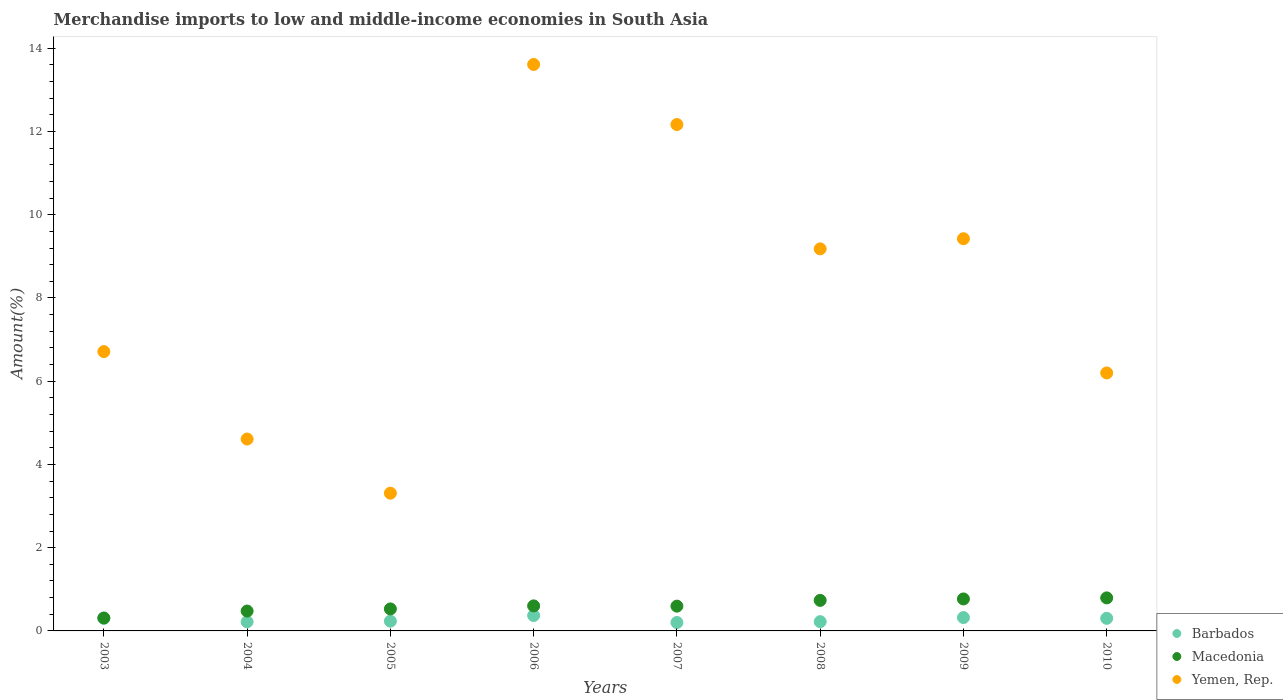How many different coloured dotlines are there?
Make the answer very short. 3. What is the percentage of amount earned from merchandise imports in Macedonia in 2010?
Provide a short and direct response. 0.79. Across all years, what is the maximum percentage of amount earned from merchandise imports in Barbados?
Make the answer very short. 0.37. Across all years, what is the minimum percentage of amount earned from merchandise imports in Barbados?
Keep it short and to the point. 0.2. What is the total percentage of amount earned from merchandise imports in Yemen, Rep. in the graph?
Make the answer very short. 65.22. What is the difference between the percentage of amount earned from merchandise imports in Yemen, Rep. in 2003 and that in 2005?
Your response must be concise. 3.4. What is the difference between the percentage of amount earned from merchandise imports in Barbados in 2004 and the percentage of amount earned from merchandise imports in Macedonia in 2007?
Offer a terse response. -0.38. What is the average percentage of amount earned from merchandise imports in Macedonia per year?
Your response must be concise. 0.6. In the year 2008, what is the difference between the percentage of amount earned from merchandise imports in Macedonia and percentage of amount earned from merchandise imports in Barbados?
Offer a very short reply. 0.51. What is the ratio of the percentage of amount earned from merchandise imports in Macedonia in 2003 to that in 2004?
Keep it short and to the point. 0.65. What is the difference between the highest and the second highest percentage of amount earned from merchandise imports in Macedonia?
Keep it short and to the point. 0.02. What is the difference between the highest and the lowest percentage of amount earned from merchandise imports in Macedonia?
Give a very brief answer. 0.48. Does the percentage of amount earned from merchandise imports in Yemen, Rep. monotonically increase over the years?
Offer a very short reply. No. How many years are there in the graph?
Provide a succinct answer. 8. Where does the legend appear in the graph?
Ensure brevity in your answer.  Bottom right. How are the legend labels stacked?
Keep it short and to the point. Vertical. What is the title of the graph?
Ensure brevity in your answer.  Merchandise imports to low and middle-income economies in South Asia. What is the label or title of the Y-axis?
Provide a succinct answer. Amount(%). What is the Amount(%) in Barbados in 2003?
Provide a succinct answer. 0.3. What is the Amount(%) in Macedonia in 2003?
Provide a short and direct response. 0.31. What is the Amount(%) of Yemen, Rep. in 2003?
Your answer should be compact. 6.71. What is the Amount(%) of Barbados in 2004?
Keep it short and to the point. 0.22. What is the Amount(%) of Macedonia in 2004?
Make the answer very short. 0.48. What is the Amount(%) in Yemen, Rep. in 2004?
Provide a succinct answer. 4.61. What is the Amount(%) in Barbados in 2005?
Your answer should be compact. 0.23. What is the Amount(%) of Macedonia in 2005?
Give a very brief answer. 0.53. What is the Amount(%) of Yemen, Rep. in 2005?
Your answer should be very brief. 3.31. What is the Amount(%) of Barbados in 2006?
Give a very brief answer. 0.37. What is the Amount(%) of Macedonia in 2006?
Provide a short and direct response. 0.6. What is the Amount(%) of Yemen, Rep. in 2006?
Make the answer very short. 13.61. What is the Amount(%) in Barbados in 2007?
Your answer should be compact. 0.2. What is the Amount(%) of Macedonia in 2007?
Your response must be concise. 0.6. What is the Amount(%) of Yemen, Rep. in 2007?
Provide a short and direct response. 12.17. What is the Amount(%) in Barbados in 2008?
Make the answer very short. 0.22. What is the Amount(%) in Macedonia in 2008?
Provide a short and direct response. 0.73. What is the Amount(%) in Yemen, Rep. in 2008?
Your response must be concise. 9.18. What is the Amount(%) of Barbados in 2009?
Ensure brevity in your answer.  0.32. What is the Amount(%) of Macedonia in 2009?
Provide a succinct answer. 0.77. What is the Amount(%) of Yemen, Rep. in 2009?
Your answer should be very brief. 9.42. What is the Amount(%) of Barbados in 2010?
Provide a succinct answer. 0.3. What is the Amount(%) of Macedonia in 2010?
Your answer should be very brief. 0.79. What is the Amount(%) in Yemen, Rep. in 2010?
Make the answer very short. 6.2. Across all years, what is the maximum Amount(%) of Barbados?
Offer a very short reply. 0.37. Across all years, what is the maximum Amount(%) in Macedonia?
Provide a short and direct response. 0.79. Across all years, what is the maximum Amount(%) in Yemen, Rep.?
Provide a short and direct response. 13.61. Across all years, what is the minimum Amount(%) of Barbados?
Keep it short and to the point. 0.2. Across all years, what is the minimum Amount(%) in Macedonia?
Ensure brevity in your answer.  0.31. Across all years, what is the minimum Amount(%) of Yemen, Rep.?
Offer a terse response. 3.31. What is the total Amount(%) of Barbados in the graph?
Ensure brevity in your answer.  2.18. What is the total Amount(%) in Macedonia in the graph?
Your response must be concise. 4.81. What is the total Amount(%) in Yemen, Rep. in the graph?
Give a very brief answer. 65.22. What is the difference between the Amount(%) in Barbados in 2003 and that in 2004?
Provide a succinct answer. 0.09. What is the difference between the Amount(%) of Macedonia in 2003 and that in 2004?
Your answer should be very brief. -0.17. What is the difference between the Amount(%) in Yemen, Rep. in 2003 and that in 2004?
Keep it short and to the point. 2.1. What is the difference between the Amount(%) in Barbados in 2003 and that in 2005?
Offer a terse response. 0.07. What is the difference between the Amount(%) in Macedonia in 2003 and that in 2005?
Your response must be concise. -0.22. What is the difference between the Amount(%) of Yemen, Rep. in 2003 and that in 2005?
Make the answer very short. 3.4. What is the difference between the Amount(%) of Barbados in 2003 and that in 2006?
Your answer should be very brief. -0.07. What is the difference between the Amount(%) in Macedonia in 2003 and that in 2006?
Your answer should be compact. -0.29. What is the difference between the Amount(%) in Yemen, Rep. in 2003 and that in 2006?
Give a very brief answer. -6.9. What is the difference between the Amount(%) of Barbados in 2003 and that in 2007?
Keep it short and to the point. 0.1. What is the difference between the Amount(%) in Macedonia in 2003 and that in 2007?
Provide a short and direct response. -0.28. What is the difference between the Amount(%) of Yemen, Rep. in 2003 and that in 2007?
Provide a succinct answer. -5.46. What is the difference between the Amount(%) in Barbados in 2003 and that in 2008?
Provide a short and direct response. 0.08. What is the difference between the Amount(%) in Macedonia in 2003 and that in 2008?
Give a very brief answer. -0.42. What is the difference between the Amount(%) of Yemen, Rep. in 2003 and that in 2008?
Give a very brief answer. -2.47. What is the difference between the Amount(%) in Barbados in 2003 and that in 2009?
Provide a succinct answer. -0.02. What is the difference between the Amount(%) in Macedonia in 2003 and that in 2009?
Your answer should be very brief. -0.46. What is the difference between the Amount(%) in Yemen, Rep. in 2003 and that in 2009?
Make the answer very short. -2.71. What is the difference between the Amount(%) of Barbados in 2003 and that in 2010?
Make the answer very short. 0. What is the difference between the Amount(%) of Macedonia in 2003 and that in 2010?
Ensure brevity in your answer.  -0.48. What is the difference between the Amount(%) in Yemen, Rep. in 2003 and that in 2010?
Provide a succinct answer. 0.51. What is the difference between the Amount(%) in Barbados in 2004 and that in 2005?
Keep it short and to the point. -0.02. What is the difference between the Amount(%) in Macedonia in 2004 and that in 2005?
Offer a terse response. -0.05. What is the difference between the Amount(%) in Yemen, Rep. in 2004 and that in 2005?
Your response must be concise. 1.3. What is the difference between the Amount(%) in Barbados in 2004 and that in 2006?
Provide a succinct answer. -0.15. What is the difference between the Amount(%) of Macedonia in 2004 and that in 2006?
Provide a succinct answer. -0.12. What is the difference between the Amount(%) of Yemen, Rep. in 2004 and that in 2006?
Provide a succinct answer. -9. What is the difference between the Amount(%) of Barbados in 2004 and that in 2007?
Offer a terse response. 0.02. What is the difference between the Amount(%) in Macedonia in 2004 and that in 2007?
Provide a short and direct response. -0.12. What is the difference between the Amount(%) of Yemen, Rep. in 2004 and that in 2007?
Offer a terse response. -7.56. What is the difference between the Amount(%) of Barbados in 2004 and that in 2008?
Your answer should be very brief. -0. What is the difference between the Amount(%) in Macedonia in 2004 and that in 2008?
Keep it short and to the point. -0.26. What is the difference between the Amount(%) in Yemen, Rep. in 2004 and that in 2008?
Offer a terse response. -4.57. What is the difference between the Amount(%) in Barbados in 2004 and that in 2009?
Ensure brevity in your answer.  -0.1. What is the difference between the Amount(%) of Macedonia in 2004 and that in 2009?
Give a very brief answer. -0.29. What is the difference between the Amount(%) in Yemen, Rep. in 2004 and that in 2009?
Provide a succinct answer. -4.81. What is the difference between the Amount(%) in Barbados in 2004 and that in 2010?
Your answer should be very brief. -0.08. What is the difference between the Amount(%) in Macedonia in 2004 and that in 2010?
Give a very brief answer. -0.32. What is the difference between the Amount(%) of Yemen, Rep. in 2004 and that in 2010?
Your answer should be compact. -1.59. What is the difference between the Amount(%) of Barbados in 2005 and that in 2006?
Provide a short and direct response. -0.14. What is the difference between the Amount(%) of Macedonia in 2005 and that in 2006?
Ensure brevity in your answer.  -0.07. What is the difference between the Amount(%) in Yemen, Rep. in 2005 and that in 2006?
Provide a short and direct response. -10.3. What is the difference between the Amount(%) in Barbados in 2005 and that in 2007?
Your answer should be compact. 0.03. What is the difference between the Amount(%) of Macedonia in 2005 and that in 2007?
Provide a short and direct response. -0.07. What is the difference between the Amount(%) in Yemen, Rep. in 2005 and that in 2007?
Ensure brevity in your answer.  -8.86. What is the difference between the Amount(%) in Barbados in 2005 and that in 2008?
Provide a succinct answer. 0.01. What is the difference between the Amount(%) of Macedonia in 2005 and that in 2008?
Your response must be concise. -0.21. What is the difference between the Amount(%) of Yemen, Rep. in 2005 and that in 2008?
Your response must be concise. -5.87. What is the difference between the Amount(%) in Barbados in 2005 and that in 2009?
Give a very brief answer. -0.09. What is the difference between the Amount(%) of Macedonia in 2005 and that in 2009?
Provide a short and direct response. -0.24. What is the difference between the Amount(%) of Yemen, Rep. in 2005 and that in 2009?
Make the answer very short. -6.11. What is the difference between the Amount(%) of Barbados in 2005 and that in 2010?
Provide a succinct answer. -0.07. What is the difference between the Amount(%) in Macedonia in 2005 and that in 2010?
Keep it short and to the point. -0.26. What is the difference between the Amount(%) of Yemen, Rep. in 2005 and that in 2010?
Provide a short and direct response. -2.89. What is the difference between the Amount(%) of Barbados in 2006 and that in 2007?
Ensure brevity in your answer.  0.17. What is the difference between the Amount(%) of Macedonia in 2006 and that in 2007?
Ensure brevity in your answer.  0.01. What is the difference between the Amount(%) of Yemen, Rep. in 2006 and that in 2007?
Your answer should be very brief. 1.44. What is the difference between the Amount(%) in Barbados in 2006 and that in 2008?
Give a very brief answer. 0.15. What is the difference between the Amount(%) of Macedonia in 2006 and that in 2008?
Your answer should be very brief. -0.13. What is the difference between the Amount(%) in Yemen, Rep. in 2006 and that in 2008?
Ensure brevity in your answer.  4.43. What is the difference between the Amount(%) in Barbados in 2006 and that in 2009?
Provide a short and direct response. 0.05. What is the difference between the Amount(%) of Macedonia in 2006 and that in 2009?
Keep it short and to the point. -0.17. What is the difference between the Amount(%) in Yemen, Rep. in 2006 and that in 2009?
Provide a short and direct response. 4.19. What is the difference between the Amount(%) of Barbados in 2006 and that in 2010?
Your answer should be compact. 0.07. What is the difference between the Amount(%) in Macedonia in 2006 and that in 2010?
Your answer should be very brief. -0.19. What is the difference between the Amount(%) in Yemen, Rep. in 2006 and that in 2010?
Your answer should be very brief. 7.41. What is the difference between the Amount(%) of Barbados in 2007 and that in 2008?
Your response must be concise. -0.02. What is the difference between the Amount(%) in Macedonia in 2007 and that in 2008?
Your response must be concise. -0.14. What is the difference between the Amount(%) in Yemen, Rep. in 2007 and that in 2008?
Provide a succinct answer. 2.99. What is the difference between the Amount(%) of Barbados in 2007 and that in 2009?
Your response must be concise. -0.12. What is the difference between the Amount(%) in Macedonia in 2007 and that in 2009?
Provide a short and direct response. -0.17. What is the difference between the Amount(%) of Yemen, Rep. in 2007 and that in 2009?
Offer a very short reply. 2.74. What is the difference between the Amount(%) of Barbados in 2007 and that in 2010?
Give a very brief answer. -0.1. What is the difference between the Amount(%) in Macedonia in 2007 and that in 2010?
Give a very brief answer. -0.2. What is the difference between the Amount(%) of Yemen, Rep. in 2007 and that in 2010?
Make the answer very short. 5.97. What is the difference between the Amount(%) of Barbados in 2008 and that in 2009?
Ensure brevity in your answer.  -0.1. What is the difference between the Amount(%) in Macedonia in 2008 and that in 2009?
Keep it short and to the point. -0.03. What is the difference between the Amount(%) of Yemen, Rep. in 2008 and that in 2009?
Your response must be concise. -0.24. What is the difference between the Amount(%) in Barbados in 2008 and that in 2010?
Make the answer very short. -0.08. What is the difference between the Amount(%) in Macedonia in 2008 and that in 2010?
Ensure brevity in your answer.  -0.06. What is the difference between the Amount(%) in Yemen, Rep. in 2008 and that in 2010?
Make the answer very short. 2.98. What is the difference between the Amount(%) in Barbados in 2009 and that in 2010?
Give a very brief answer. 0.02. What is the difference between the Amount(%) in Macedonia in 2009 and that in 2010?
Your response must be concise. -0.03. What is the difference between the Amount(%) in Yemen, Rep. in 2009 and that in 2010?
Offer a very short reply. 3.23. What is the difference between the Amount(%) in Barbados in 2003 and the Amount(%) in Macedonia in 2004?
Provide a succinct answer. -0.17. What is the difference between the Amount(%) in Barbados in 2003 and the Amount(%) in Yemen, Rep. in 2004?
Offer a very short reply. -4.31. What is the difference between the Amount(%) in Macedonia in 2003 and the Amount(%) in Yemen, Rep. in 2004?
Your response must be concise. -4.3. What is the difference between the Amount(%) of Barbados in 2003 and the Amount(%) of Macedonia in 2005?
Your answer should be compact. -0.23. What is the difference between the Amount(%) in Barbados in 2003 and the Amount(%) in Yemen, Rep. in 2005?
Your answer should be compact. -3.01. What is the difference between the Amount(%) in Macedonia in 2003 and the Amount(%) in Yemen, Rep. in 2005?
Provide a succinct answer. -3. What is the difference between the Amount(%) in Barbados in 2003 and the Amount(%) in Macedonia in 2006?
Give a very brief answer. -0.3. What is the difference between the Amount(%) in Barbados in 2003 and the Amount(%) in Yemen, Rep. in 2006?
Your response must be concise. -13.31. What is the difference between the Amount(%) in Macedonia in 2003 and the Amount(%) in Yemen, Rep. in 2006?
Your answer should be compact. -13.3. What is the difference between the Amount(%) of Barbados in 2003 and the Amount(%) of Macedonia in 2007?
Your response must be concise. -0.29. What is the difference between the Amount(%) in Barbados in 2003 and the Amount(%) in Yemen, Rep. in 2007?
Your answer should be very brief. -11.86. What is the difference between the Amount(%) of Macedonia in 2003 and the Amount(%) of Yemen, Rep. in 2007?
Ensure brevity in your answer.  -11.86. What is the difference between the Amount(%) in Barbados in 2003 and the Amount(%) in Macedonia in 2008?
Offer a very short reply. -0.43. What is the difference between the Amount(%) in Barbados in 2003 and the Amount(%) in Yemen, Rep. in 2008?
Keep it short and to the point. -8.88. What is the difference between the Amount(%) of Macedonia in 2003 and the Amount(%) of Yemen, Rep. in 2008?
Provide a succinct answer. -8.87. What is the difference between the Amount(%) in Barbados in 2003 and the Amount(%) in Macedonia in 2009?
Provide a succinct answer. -0.46. What is the difference between the Amount(%) of Barbados in 2003 and the Amount(%) of Yemen, Rep. in 2009?
Make the answer very short. -9.12. What is the difference between the Amount(%) of Macedonia in 2003 and the Amount(%) of Yemen, Rep. in 2009?
Provide a short and direct response. -9.11. What is the difference between the Amount(%) of Barbados in 2003 and the Amount(%) of Macedonia in 2010?
Offer a terse response. -0.49. What is the difference between the Amount(%) in Barbados in 2003 and the Amount(%) in Yemen, Rep. in 2010?
Offer a terse response. -5.9. What is the difference between the Amount(%) of Macedonia in 2003 and the Amount(%) of Yemen, Rep. in 2010?
Offer a terse response. -5.89. What is the difference between the Amount(%) in Barbados in 2004 and the Amount(%) in Macedonia in 2005?
Give a very brief answer. -0.31. What is the difference between the Amount(%) of Barbados in 2004 and the Amount(%) of Yemen, Rep. in 2005?
Provide a succinct answer. -3.09. What is the difference between the Amount(%) in Macedonia in 2004 and the Amount(%) in Yemen, Rep. in 2005?
Your answer should be compact. -2.83. What is the difference between the Amount(%) in Barbados in 2004 and the Amount(%) in Macedonia in 2006?
Give a very brief answer. -0.38. What is the difference between the Amount(%) of Barbados in 2004 and the Amount(%) of Yemen, Rep. in 2006?
Keep it short and to the point. -13.39. What is the difference between the Amount(%) in Macedonia in 2004 and the Amount(%) in Yemen, Rep. in 2006?
Provide a short and direct response. -13.13. What is the difference between the Amount(%) in Barbados in 2004 and the Amount(%) in Macedonia in 2007?
Provide a short and direct response. -0.38. What is the difference between the Amount(%) in Barbados in 2004 and the Amount(%) in Yemen, Rep. in 2007?
Provide a short and direct response. -11.95. What is the difference between the Amount(%) of Macedonia in 2004 and the Amount(%) of Yemen, Rep. in 2007?
Your answer should be compact. -11.69. What is the difference between the Amount(%) of Barbados in 2004 and the Amount(%) of Macedonia in 2008?
Make the answer very short. -0.52. What is the difference between the Amount(%) in Barbados in 2004 and the Amount(%) in Yemen, Rep. in 2008?
Provide a succinct answer. -8.96. What is the difference between the Amount(%) in Macedonia in 2004 and the Amount(%) in Yemen, Rep. in 2008?
Provide a short and direct response. -8.7. What is the difference between the Amount(%) in Barbados in 2004 and the Amount(%) in Macedonia in 2009?
Provide a short and direct response. -0.55. What is the difference between the Amount(%) of Barbados in 2004 and the Amount(%) of Yemen, Rep. in 2009?
Provide a succinct answer. -9.21. What is the difference between the Amount(%) in Macedonia in 2004 and the Amount(%) in Yemen, Rep. in 2009?
Your response must be concise. -8.95. What is the difference between the Amount(%) in Barbados in 2004 and the Amount(%) in Macedonia in 2010?
Your answer should be very brief. -0.58. What is the difference between the Amount(%) of Barbados in 2004 and the Amount(%) of Yemen, Rep. in 2010?
Your response must be concise. -5.98. What is the difference between the Amount(%) in Macedonia in 2004 and the Amount(%) in Yemen, Rep. in 2010?
Offer a very short reply. -5.72. What is the difference between the Amount(%) in Barbados in 2005 and the Amount(%) in Macedonia in 2006?
Your answer should be very brief. -0.37. What is the difference between the Amount(%) of Barbados in 2005 and the Amount(%) of Yemen, Rep. in 2006?
Your answer should be compact. -13.38. What is the difference between the Amount(%) in Macedonia in 2005 and the Amount(%) in Yemen, Rep. in 2006?
Ensure brevity in your answer.  -13.08. What is the difference between the Amount(%) of Barbados in 2005 and the Amount(%) of Macedonia in 2007?
Your answer should be very brief. -0.36. What is the difference between the Amount(%) of Barbados in 2005 and the Amount(%) of Yemen, Rep. in 2007?
Your answer should be compact. -11.93. What is the difference between the Amount(%) in Macedonia in 2005 and the Amount(%) in Yemen, Rep. in 2007?
Provide a succinct answer. -11.64. What is the difference between the Amount(%) of Barbados in 2005 and the Amount(%) of Macedonia in 2008?
Provide a succinct answer. -0.5. What is the difference between the Amount(%) in Barbados in 2005 and the Amount(%) in Yemen, Rep. in 2008?
Ensure brevity in your answer.  -8.95. What is the difference between the Amount(%) in Macedonia in 2005 and the Amount(%) in Yemen, Rep. in 2008?
Your answer should be very brief. -8.65. What is the difference between the Amount(%) of Barbados in 2005 and the Amount(%) of Macedonia in 2009?
Provide a succinct answer. -0.53. What is the difference between the Amount(%) in Barbados in 2005 and the Amount(%) in Yemen, Rep. in 2009?
Give a very brief answer. -9.19. What is the difference between the Amount(%) in Macedonia in 2005 and the Amount(%) in Yemen, Rep. in 2009?
Offer a terse response. -8.9. What is the difference between the Amount(%) in Barbados in 2005 and the Amount(%) in Macedonia in 2010?
Keep it short and to the point. -0.56. What is the difference between the Amount(%) of Barbados in 2005 and the Amount(%) of Yemen, Rep. in 2010?
Your answer should be very brief. -5.96. What is the difference between the Amount(%) of Macedonia in 2005 and the Amount(%) of Yemen, Rep. in 2010?
Offer a terse response. -5.67. What is the difference between the Amount(%) in Barbados in 2006 and the Amount(%) in Macedonia in 2007?
Provide a short and direct response. -0.23. What is the difference between the Amount(%) in Barbados in 2006 and the Amount(%) in Yemen, Rep. in 2007?
Give a very brief answer. -11.8. What is the difference between the Amount(%) in Macedonia in 2006 and the Amount(%) in Yemen, Rep. in 2007?
Keep it short and to the point. -11.57. What is the difference between the Amount(%) in Barbados in 2006 and the Amount(%) in Macedonia in 2008?
Your answer should be compact. -0.36. What is the difference between the Amount(%) in Barbados in 2006 and the Amount(%) in Yemen, Rep. in 2008?
Provide a succinct answer. -8.81. What is the difference between the Amount(%) in Macedonia in 2006 and the Amount(%) in Yemen, Rep. in 2008?
Your answer should be compact. -8.58. What is the difference between the Amount(%) in Barbados in 2006 and the Amount(%) in Macedonia in 2009?
Keep it short and to the point. -0.4. What is the difference between the Amount(%) in Barbados in 2006 and the Amount(%) in Yemen, Rep. in 2009?
Offer a terse response. -9.05. What is the difference between the Amount(%) in Macedonia in 2006 and the Amount(%) in Yemen, Rep. in 2009?
Your answer should be compact. -8.82. What is the difference between the Amount(%) in Barbados in 2006 and the Amount(%) in Macedonia in 2010?
Offer a very short reply. -0.42. What is the difference between the Amount(%) in Barbados in 2006 and the Amount(%) in Yemen, Rep. in 2010?
Your answer should be very brief. -5.83. What is the difference between the Amount(%) in Macedonia in 2006 and the Amount(%) in Yemen, Rep. in 2010?
Your answer should be very brief. -5.6. What is the difference between the Amount(%) in Barbados in 2007 and the Amount(%) in Macedonia in 2008?
Give a very brief answer. -0.53. What is the difference between the Amount(%) of Barbados in 2007 and the Amount(%) of Yemen, Rep. in 2008?
Your response must be concise. -8.98. What is the difference between the Amount(%) in Macedonia in 2007 and the Amount(%) in Yemen, Rep. in 2008?
Provide a succinct answer. -8.59. What is the difference between the Amount(%) of Barbados in 2007 and the Amount(%) of Macedonia in 2009?
Offer a very short reply. -0.57. What is the difference between the Amount(%) of Barbados in 2007 and the Amount(%) of Yemen, Rep. in 2009?
Your response must be concise. -9.22. What is the difference between the Amount(%) of Macedonia in 2007 and the Amount(%) of Yemen, Rep. in 2009?
Give a very brief answer. -8.83. What is the difference between the Amount(%) in Barbados in 2007 and the Amount(%) in Macedonia in 2010?
Offer a terse response. -0.59. What is the difference between the Amount(%) of Barbados in 2007 and the Amount(%) of Yemen, Rep. in 2010?
Provide a short and direct response. -6. What is the difference between the Amount(%) of Macedonia in 2007 and the Amount(%) of Yemen, Rep. in 2010?
Keep it short and to the point. -5.6. What is the difference between the Amount(%) of Barbados in 2008 and the Amount(%) of Macedonia in 2009?
Keep it short and to the point. -0.55. What is the difference between the Amount(%) in Barbados in 2008 and the Amount(%) in Yemen, Rep. in 2009?
Provide a short and direct response. -9.2. What is the difference between the Amount(%) in Macedonia in 2008 and the Amount(%) in Yemen, Rep. in 2009?
Your response must be concise. -8.69. What is the difference between the Amount(%) of Barbados in 2008 and the Amount(%) of Macedonia in 2010?
Ensure brevity in your answer.  -0.57. What is the difference between the Amount(%) in Barbados in 2008 and the Amount(%) in Yemen, Rep. in 2010?
Provide a succinct answer. -5.98. What is the difference between the Amount(%) of Macedonia in 2008 and the Amount(%) of Yemen, Rep. in 2010?
Offer a terse response. -5.46. What is the difference between the Amount(%) in Barbados in 2009 and the Amount(%) in Macedonia in 2010?
Provide a succinct answer. -0.47. What is the difference between the Amount(%) of Barbados in 2009 and the Amount(%) of Yemen, Rep. in 2010?
Offer a terse response. -5.88. What is the difference between the Amount(%) in Macedonia in 2009 and the Amount(%) in Yemen, Rep. in 2010?
Your response must be concise. -5.43. What is the average Amount(%) of Barbados per year?
Offer a terse response. 0.27. What is the average Amount(%) of Macedonia per year?
Make the answer very short. 0.6. What is the average Amount(%) in Yemen, Rep. per year?
Offer a very short reply. 8.15. In the year 2003, what is the difference between the Amount(%) in Barbados and Amount(%) in Macedonia?
Offer a very short reply. -0.01. In the year 2003, what is the difference between the Amount(%) of Barbados and Amount(%) of Yemen, Rep.?
Provide a succinct answer. -6.41. In the year 2003, what is the difference between the Amount(%) in Macedonia and Amount(%) in Yemen, Rep.?
Offer a terse response. -6.4. In the year 2004, what is the difference between the Amount(%) in Barbados and Amount(%) in Macedonia?
Ensure brevity in your answer.  -0.26. In the year 2004, what is the difference between the Amount(%) of Barbados and Amount(%) of Yemen, Rep.?
Make the answer very short. -4.39. In the year 2004, what is the difference between the Amount(%) in Macedonia and Amount(%) in Yemen, Rep.?
Provide a short and direct response. -4.13. In the year 2005, what is the difference between the Amount(%) in Barbados and Amount(%) in Macedonia?
Offer a very short reply. -0.29. In the year 2005, what is the difference between the Amount(%) in Barbados and Amount(%) in Yemen, Rep.?
Offer a terse response. -3.08. In the year 2005, what is the difference between the Amount(%) in Macedonia and Amount(%) in Yemen, Rep.?
Give a very brief answer. -2.78. In the year 2006, what is the difference between the Amount(%) of Barbados and Amount(%) of Macedonia?
Your answer should be very brief. -0.23. In the year 2006, what is the difference between the Amount(%) of Barbados and Amount(%) of Yemen, Rep.?
Offer a very short reply. -13.24. In the year 2006, what is the difference between the Amount(%) in Macedonia and Amount(%) in Yemen, Rep.?
Give a very brief answer. -13.01. In the year 2007, what is the difference between the Amount(%) of Barbados and Amount(%) of Macedonia?
Provide a short and direct response. -0.39. In the year 2007, what is the difference between the Amount(%) of Barbados and Amount(%) of Yemen, Rep.?
Your response must be concise. -11.97. In the year 2007, what is the difference between the Amount(%) in Macedonia and Amount(%) in Yemen, Rep.?
Provide a succinct answer. -11.57. In the year 2008, what is the difference between the Amount(%) of Barbados and Amount(%) of Macedonia?
Your response must be concise. -0.51. In the year 2008, what is the difference between the Amount(%) in Barbados and Amount(%) in Yemen, Rep.?
Make the answer very short. -8.96. In the year 2008, what is the difference between the Amount(%) of Macedonia and Amount(%) of Yemen, Rep.?
Provide a short and direct response. -8.45. In the year 2009, what is the difference between the Amount(%) of Barbados and Amount(%) of Macedonia?
Make the answer very short. -0.45. In the year 2009, what is the difference between the Amount(%) of Barbados and Amount(%) of Yemen, Rep.?
Ensure brevity in your answer.  -9.1. In the year 2009, what is the difference between the Amount(%) of Macedonia and Amount(%) of Yemen, Rep.?
Offer a very short reply. -8.66. In the year 2010, what is the difference between the Amount(%) in Barbados and Amount(%) in Macedonia?
Keep it short and to the point. -0.49. In the year 2010, what is the difference between the Amount(%) of Barbados and Amount(%) of Yemen, Rep.?
Offer a very short reply. -5.9. In the year 2010, what is the difference between the Amount(%) of Macedonia and Amount(%) of Yemen, Rep.?
Offer a very short reply. -5.41. What is the ratio of the Amount(%) of Barbados in 2003 to that in 2004?
Make the answer very short. 1.39. What is the ratio of the Amount(%) in Macedonia in 2003 to that in 2004?
Offer a very short reply. 0.65. What is the ratio of the Amount(%) in Yemen, Rep. in 2003 to that in 2004?
Ensure brevity in your answer.  1.46. What is the ratio of the Amount(%) in Barbados in 2003 to that in 2005?
Offer a terse response. 1.29. What is the ratio of the Amount(%) of Macedonia in 2003 to that in 2005?
Offer a very short reply. 0.59. What is the ratio of the Amount(%) of Yemen, Rep. in 2003 to that in 2005?
Your answer should be compact. 2.03. What is the ratio of the Amount(%) in Barbados in 2003 to that in 2006?
Your answer should be very brief. 0.82. What is the ratio of the Amount(%) of Macedonia in 2003 to that in 2006?
Ensure brevity in your answer.  0.52. What is the ratio of the Amount(%) of Yemen, Rep. in 2003 to that in 2006?
Your response must be concise. 0.49. What is the ratio of the Amount(%) of Barbados in 2003 to that in 2007?
Make the answer very short. 1.5. What is the ratio of the Amount(%) in Macedonia in 2003 to that in 2007?
Your answer should be very brief. 0.52. What is the ratio of the Amount(%) of Yemen, Rep. in 2003 to that in 2007?
Keep it short and to the point. 0.55. What is the ratio of the Amount(%) of Barbados in 2003 to that in 2008?
Provide a succinct answer. 1.36. What is the ratio of the Amount(%) of Macedonia in 2003 to that in 2008?
Provide a short and direct response. 0.42. What is the ratio of the Amount(%) of Yemen, Rep. in 2003 to that in 2008?
Your response must be concise. 0.73. What is the ratio of the Amount(%) in Barbados in 2003 to that in 2009?
Make the answer very short. 0.95. What is the ratio of the Amount(%) in Macedonia in 2003 to that in 2009?
Provide a succinct answer. 0.4. What is the ratio of the Amount(%) in Yemen, Rep. in 2003 to that in 2009?
Ensure brevity in your answer.  0.71. What is the ratio of the Amount(%) of Macedonia in 2003 to that in 2010?
Offer a terse response. 0.39. What is the ratio of the Amount(%) in Yemen, Rep. in 2003 to that in 2010?
Your answer should be compact. 1.08. What is the ratio of the Amount(%) in Barbados in 2004 to that in 2005?
Provide a succinct answer. 0.93. What is the ratio of the Amount(%) of Macedonia in 2004 to that in 2005?
Your response must be concise. 0.9. What is the ratio of the Amount(%) of Yemen, Rep. in 2004 to that in 2005?
Your answer should be very brief. 1.39. What is the ratio of the Amount(%) of Barbados in 2004 to that in 2006?
Give a very brief answer. 0.59. What is the ratio of the Amount(%) of Macedonia in 2004 to that in 2006?
Your answer should be very brief. 0.79. What is the ratio of the Amount(%) in Yemen, Rep. in 2004 to that in 2006?
Keep it short and to the point. 0.34. What is the ratio of the Amount(%) in Barbados in 2004 to that in 2007?
Offer a very short reply. 1.08. What is the ratio of the Amount(%) in Macedonia in 2004 to that in 2007?
Ensure brevity in your answer.  0.8. What is the ratio of the Amount(%) in Yemen, Rep. in 2004 to that in 2007?
Give a very brief answer. 0.38. What is the ratio of the Amount(%) of Barbados in 2004 to that in 2008?
Your response must be concise. 0.98. What is the ratio of the Amount(%) of Macedonia in 2004 to that in 2008?
Your answer should be compact. 0.65. What is the ratio of the Amount(%) of Yemen, Rep. in 2004 to that in 2008?
Offer a terse response. 0.5. What is the ratio of the Amount(%) in Barbados in 2004 to that in 2009?
Provide a short and direct response. 0.68. What is the ratio of the Amount(%) in Macedonia in 2004 to that in 2009?
Your response must be concise. 0.62. What is the ratio of the Amount(%) of Yemen, Rep. in 2004 to that in 2009?
Your response must be concise. 0.49. What is the ratio of the Amount(%) in Barbados in 2004 to that in 2010?
Your answer should be compact. 0.72. What is the ratio of the Amount(%) of Macedonia in 2004 to that in 2010?
Provide a succinct answer. 0.6. What is the ratio of the Amount(%) of Yemen, Rep. in 2004 to that in 2010?
Provide a short and direct response. 0.74. What is the ratio of the Amount(%) of Barbados in 2005 to that in 2006?
Your answer should be very brief. 0.63. What is the ratio of the Amount(%) in Macedonia in 2005 to that in 2006?
Your response must be concise. 0.88. What is the ratio of the Amount(%) in Yemen, Rep. in 2005 to that in 2006?
Ensure brevity in your answer.  0.24. What is the ratio of the Amount(%) of Barbados in 2005 to that in 2007?
Offer a terse response. 1.16. What is the ratio of the Amount(%) of Macedonia in 2005 to that in 2007?
Provide a short and direct response. 0.89. What is the ratio of the Amount(%) of Yemen, Rep. in 2005 to that in 2007?
Provide a short and direct response. 0.27. What is the ratio of the Amount(%) of Barbados in 2005 to that in 2008?
Your response must be concise. 1.05. What is the ratio of the Amount(%) of Macedonia in 2005 to that in 2008?
Your answer should be compact. 0.72. What is the ratio of the Amount(%) in Yemen, Rep. in 2005 to that in 2008?
Provide a succinct answer. 0.36. What is the ratio of the Amount(%) in Barbados in 2005 to that in 2009?
Your response must be concise. 0.73. What is the ratio of the Amount(%) of Macedonia in 2005 to that in 2009?
Provide a short and direct response. 0.69. What is the ratio of the Amount(%) of Yemen, Rep. in 2005 to that in 2009?
Your response must be concise. 0.35. What is the ratio of the Amount(%) of Barbados in 2005 to that in 2010?
Keep it short and to the point. 0.77. What is the ratio of the Amount(%) of Macedonia in 2005 to that in 2010?
Your response must be concise. 0.67. What is the ratio of the Amount(%) of Yemen, Rep. in 2005 to that in 2010?
Give a very brief answer. 0.53. What is the ratio of the Amount(%) of Barbados in 2006 to that in 2007?
Provide a short and direct response. 1.83. What is the ratio of the Amount(%) of Macedonia in 2006 to that in 2007?
Offer a terse response. 1.01. What is the ratio of the Amount(%) in Yemen, Rep. in 2006 to that in 2007?
Give a very brief answer. 1.12. What is the ratio of the Amount(%) of Barbados in 2006 to that in 2008?
Offer a very short reply. 1.66. What is the ratio of the Amount(%) of Macedonia in 2006 to that in 2008?
Make the answer very short. 0.82. What is the ratio of the Amount(%) in Yemen, Rep. in 2006 to that in 2008?
Offer a terse response. 1.48. What is the ratio of the Amount(%) in Barbados in 2006 to that in 2009?
Your response must be concise. 1.15. What is the ratio of the Amount(%) in Macedonia in 2006 to that in 2009?
Ensure brevity in your answer.  0.78. What is the ratio of the Amount(%) in Yemen, Rep. in 2006 to that in 2009?
Give a very brief answer. 1.44. What is the ratio of the Amount(%) of Barbados in 2006 to that in 2010?
Provide a short and direct response. 1.22. What is the ratio of the Amount(%) in Macedonia in 2006 to that in 2010?
Your response must be concise. 0.76. What is the ratio of the Amount(%) in Yemen, Rep. in 2006 to that in 2010?
Your response must be concise. 2.2. What is the ratio of the Amount(%) in Barbados in 2007 to that in 2008?
Keep it short and to the point. 0.91. What is the ratio of the Amount(%) in Macedonia in 2007 to that in 2008?
Provide a succinct answer. 0.81. What is the ratio of the Amount(%) in Yemen, Rep. in 2007 to that in 2008?
Your response must be concise. 1.33. What is the ratio of the Amount(%) of Barbados in 2007 to that in 2009?
Offer a very short reply. 0.63. What is the ratio of the Amount(%) of Macedonia in 2007 to that in 2009?
Offer a terse response. 0.78. What is the ratio of the Amount(%) in Yemen, Rep. in 2007 to that in 2009?
Offer a terse response. 1.29. What is the ratio of the Amount(%) in Barbados in 2007 to that in 2010?
Offer a very short reply. 0.67. What is the ratio of the Amount(%) of Macedonia in 2007 to that in 2010?
Your response must be concise. 0.75. What is the ratio of the Amount(%) of Yemen, Rep. in 2007 to that in 2010?
Your response must be concise. 1.96. What is the ratio of the Amount(%) of Barbados in 2008 to that in 2009?
Ensure brevity in your answer.  0.69. What is the ratio of the Amount(%) in Macedonia in 2008 to that in 2009?
Your answer should be very brief. 0.95. What is the ratio of the Amount(%) of Yemen, Rep. in 2008 to that in 2009?
Keep it short and to the point. 0.97. What is the ratio of the Amount(%) in Barbados in 2008 to that in 2010?
Your answer should be very brief. 0.74. What is the ratio of the Amount(%) in Macedonia in 2008 to that in 2010?
Make the answer very short. 0.92. What is the ratio of the Amount(%) of Yemen, Rep. in 2008 to that in 2010?
Your response must be concise. 1.48. What is the ratio of the Amount(%) in Barbados in 2009 to that in 2010?
Make the answer very short. 1.06. What is the ratio of the Amount(%) of Macedonia in 2009 to that in 2010?
Provide a succinct answer. 0.97. What is the ratio of the Amount(%) in Yemen, Rep. in 2009 to that in 2010?
Ensure brevity in your answer.  1.52. What is the difference between the highest and the second highest Amount(%) in Barbados?
Your response must be concise. 0.05. What is the difference between the highest and the second highest Amount(%) in Macedonia?
Your response must be concise. 0.03. What is the difference between the highest and the second highest Amount(%) of Yemen, Rep.?
Your answer should be very brief. 1.44. What is the difference between the highest and the lowest Amount(%) of Barbados?
Offer a terse response. 0.17. What is the difference between the highest and the lowest Amount(%) in Macedonia?
Make the answer very short. 0.48. What is the difference between the highest and the lowest Amount(%) in Yemen, Rep.?
Your response must be concise. 10.3. 